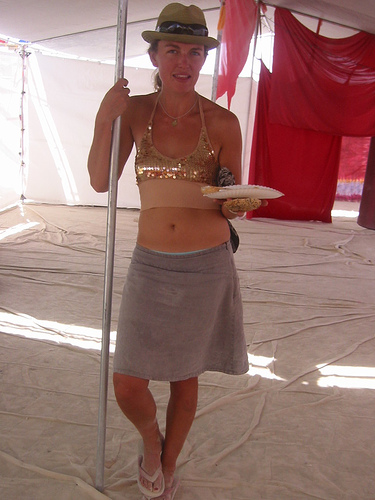<image>
Can you confirm if the plate is above the ground? Yes. The plate is positioned above the ground in the vertical space, higher up in the scene. 